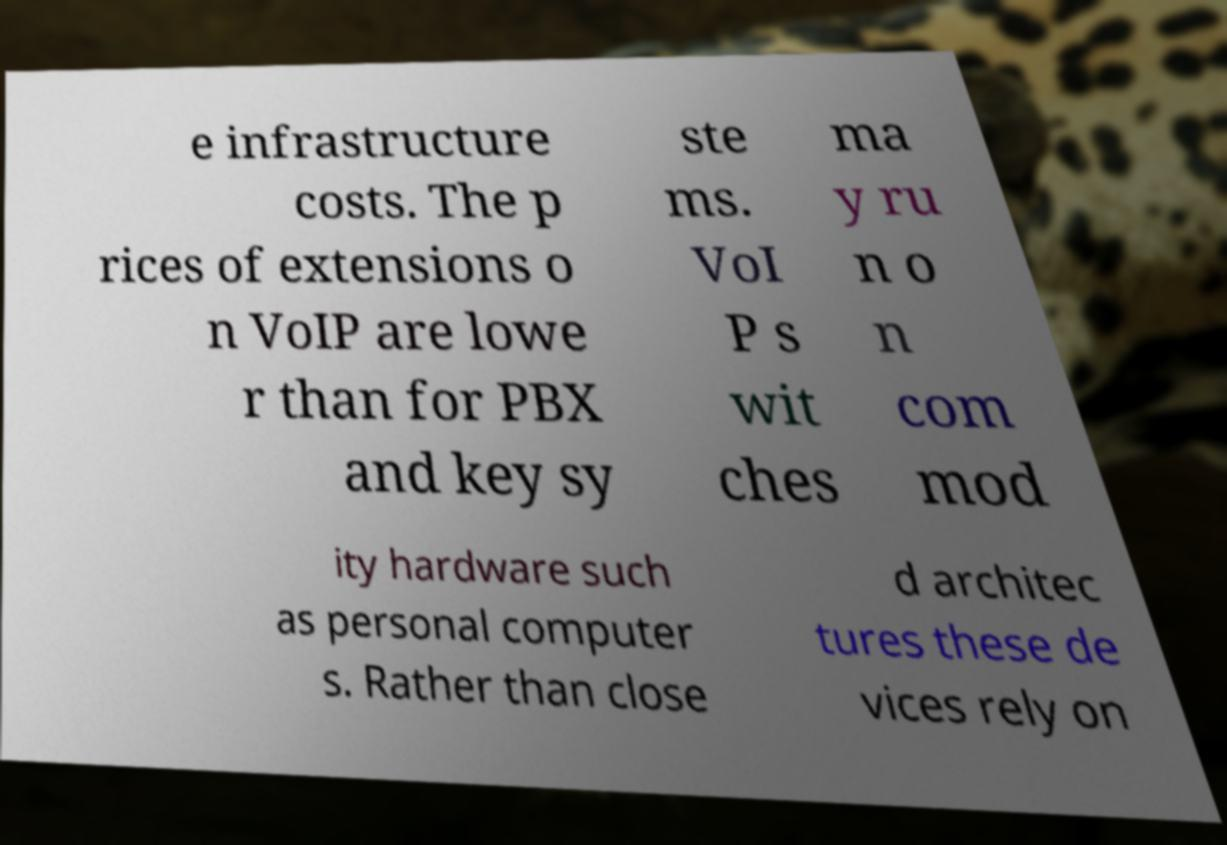I need the written content from this picture converted into text. Can you do that? e infrastructure costs. The p rices of extensions o n VoIP are lowe r than for PBX and key sy ste ms. VoI P s wit ches ma y ru n o n com mod ity hardware such as personal computer s. Rather than close d architec tures these de vices rely on 